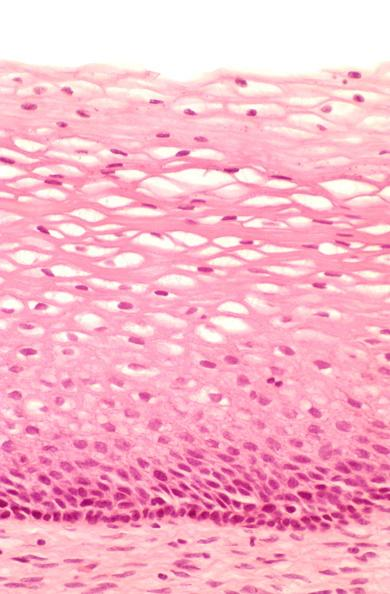s female reproductive present?
Answer the question using a single word or phrase. Yes 